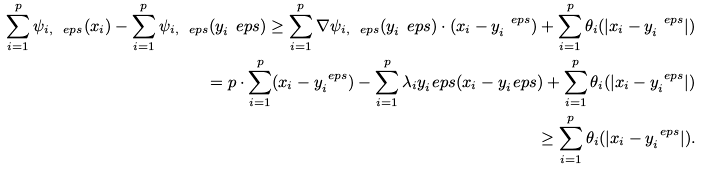<formula> <loc_0><loc_0><loc_500><loc_500>\sum _ { i = 1 } ^ { p } \psi _ { i , \ e p s } ( x _ { i } ) - \sum _ { i = 1 } ^ { p } \psi _ { i , \ e p s } ( y _ { i } ^ { \ } e p s ) \geq \sum _ { i = 1 } ^ { p } \nabla \psi _ { i , \ e p s } ( y _ { i } ^ { \ } e p s ) \cdot ( x _ { i } - y _ { i } ^ { \ e p s } ) + \sum _ { i = 1 } ^ { p } \theta _ { i } ( | x _ { i } - y _ { i } ^ { \ e p s } | ) \\ = p \cdot \sum _ { i = 1 } ^ { p } ( x _ { i } - y _ { i } ^ { \ e p s } ) - \sum _ { i = 1 } ^ { p } \lambda _ { i } y _ { i } ^ { \ } e p s ( x _ { i } - y _ { i } ^ { \ } e p s ) + \sum _ { i = 1 } ^ { p } \theta _ { i } ( | x _ { i } - y _ { i } ^ { \ e p s } | ) \\ \geq \sum _ { i = 1 } ^ { p } \theta _ { i } ( | x _ { i } - y _ { i } ^ { \ e p s } | ) .</formula> 